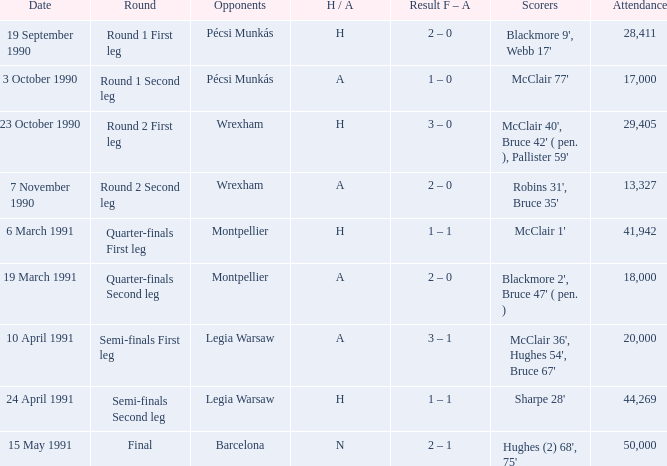What is the attendance number in the final round? 50000.0. 